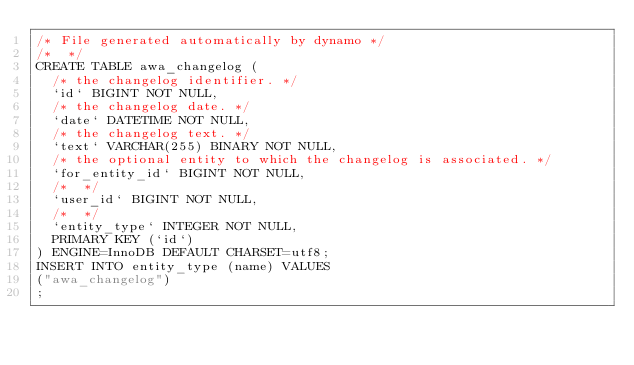<code> <loc_0><loc_0><loc_500><loc_500><_SQL_>/* File generated automatically by dynamo */
/*  */
CREATE TABLE awa_changelog (
  /* the changelog identifier. */
  `id` BIGINT NOT NULL,
  /* the changelog date. */
  `date` DATETIME NOT NULL,
  /* the changelog text. */
  `text` VARCHAR(255) BINARY NOT NULL,
  /* the optional entity to which the changelog is associated. */
  `for_entity_id` BIGINT NOT NULL,
  /*  */
  `user_id` BIGINT NOT NULL,
  /*  */
  `entity_type` INTEGER NOT NULL,
  PRIMARY KEY (`id`)
) ENGINE=InnoDB DEFAULT CHARSET=utf8;
INSERT INTO entity_type (name) VALUES
("awa_changelog")
;
</code> 